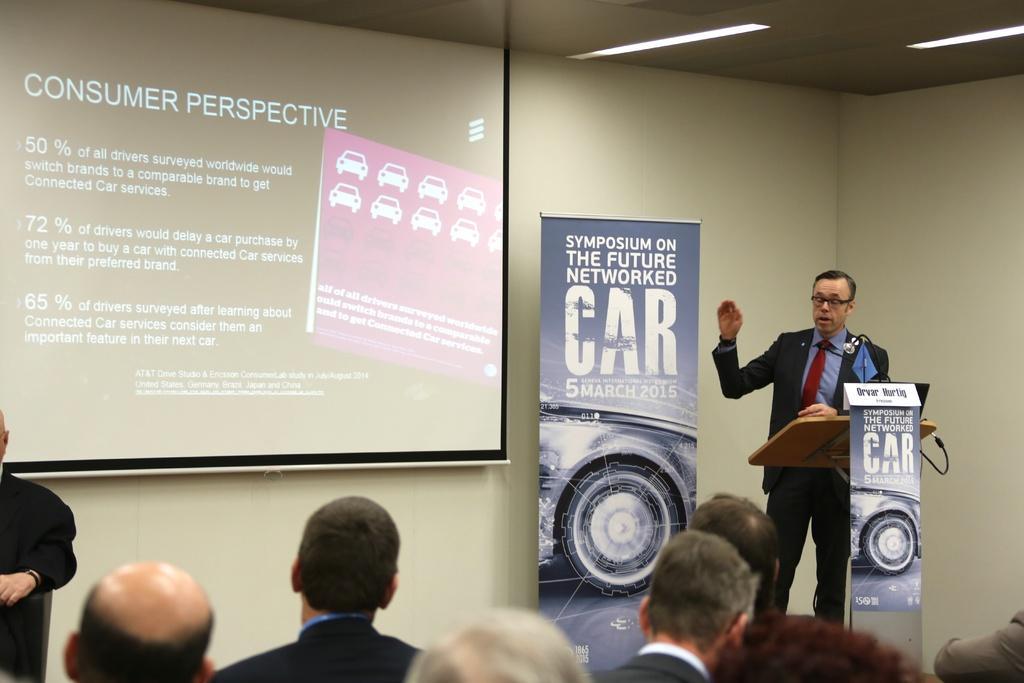Please provide a concise description of this image. In this image I can see a person wearing ,shirt, tie, blazer and pant is standing in front of the podium and I can see a microphone in front of him. I can see few other persons and few banners. In the background I can see the wall, the ceiling, few lights to the ceiling and the projection screen. 